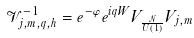Convert formula to latex. <formula><loc_0><loc_0><loc_500><loc_500>\mathcal { V } _ { j , m , q , h } ^ { - 1 } = e ^ { - \varphi } e ^ { i q W } V _ { \frac { \mathcal { N } } { U ( 1 ) } } V _ { j , m }</formula> 